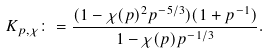Convert formula to latex. <formula><loc_0><loc_0><loc_500><loc_500>K _ { p , \chi } \colon = \frac { ( 1 - \chi ( p ) ^ { 2 } p ^ { - 5 / 3 } ) ( 1 + p ^ { - 1 } ) } { 1 - \chi ( p ) p ^ { - 1 / 3 } } .</formula> 